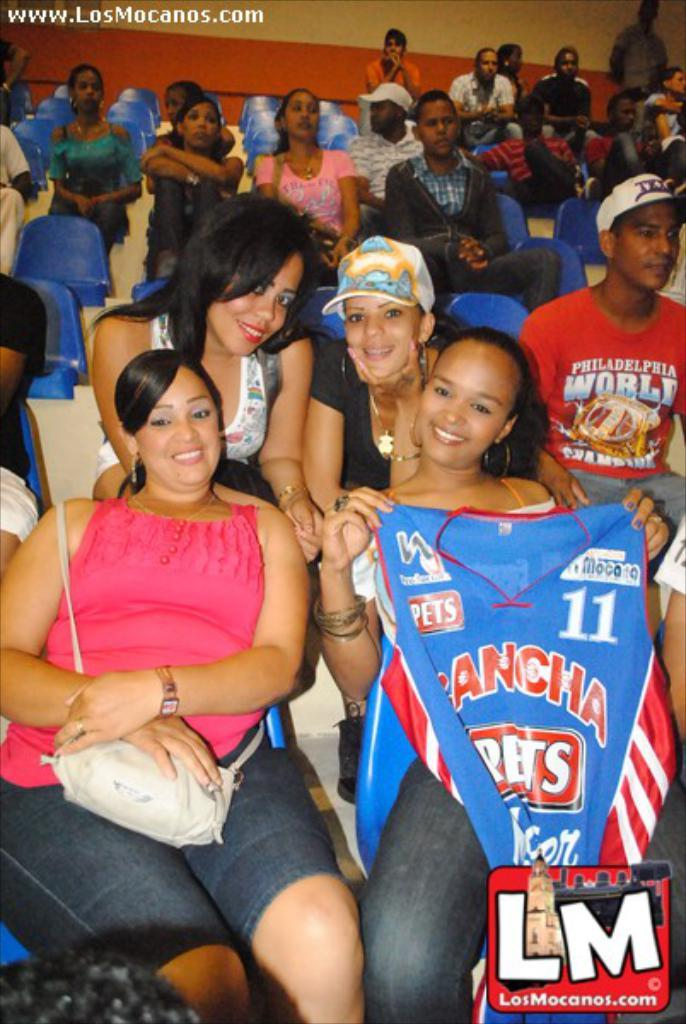<image>
Provide a brief description of the given image. A photo that says www.LosMocanos.com in the upper left corner.. 